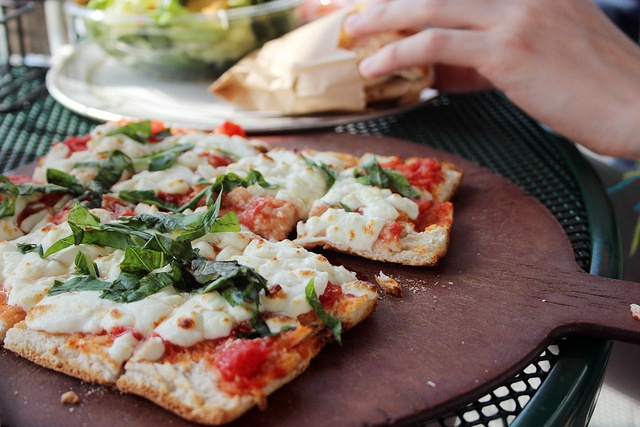Describe the objects in this image and their specific colors. I can see dining table in darkgray, black, gray, and lightgray tones, pizza in darkgray, lightgray, black, and tan tones, people in darkgray and gray tones, and bowl in darkgray, olive, beige, and lightgray tones in this image. 